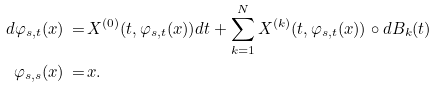Convert formula to latex. <formula><loc_0><loc_0><loc_500><loc_500>d \varphi _ { s , t } ( x ) \, = \, & X ^ { ( 0 ) } ( t , \varphi _ { s , t } ( x ) ) d t + \sum _ { k = 1 } ^ { N } X ^ { ( k ) } ( t , \varphi _ { s , t } ( x ) ) \circ d B _ { k } ( t ) \\ \varphi _ { s , s } ( x ) \, = \, & x .</formula> 